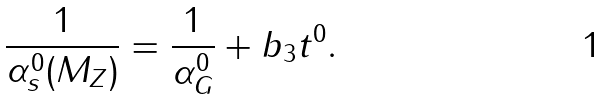<formula> <loc_0><loc_0><loc_500><loc_500>\frac { 1 } { \alpha _ { s } ^ { 0 } ( M _ { Z } ) } = \frac { 1 } { \alpha _ { G } ^ { 0 } } + b _ { 3 } t ^ { 0 } .</formula> 